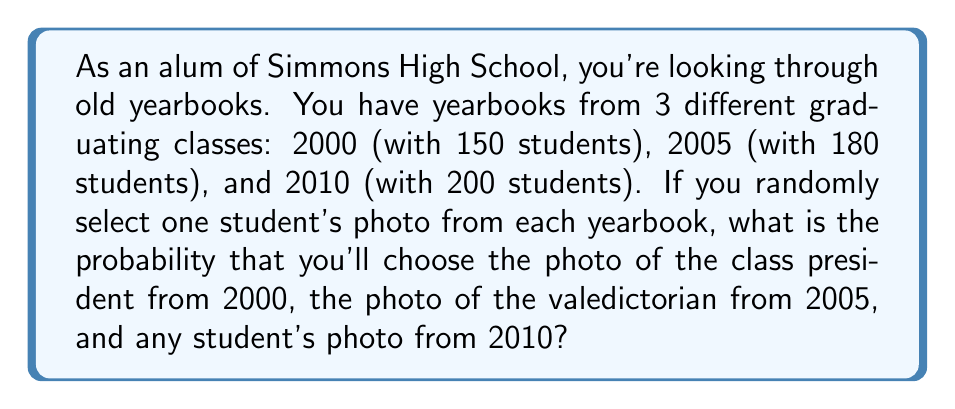Help me with this question. Let's approach this step-by-step:

1) For the year 2000:
   - There are 150 students in total.
   - We need to select the class president, which is 1 specific student.
   - Probability = $\frac{1}{150}$

2) For the year 2005:
   - There are 180 students in total.
   - We need to select the valedictorian, which is 1 specific student.
   - Probability = $\frac{1}{180}$

3) For the year 2010:
   - There are 200 students in total.
   - We can select any student, so all choices are favorable.
   - Probability = $\frac{200}{200} = 1$

4) Since we're selecting one photo from each yearbook independently, we need to multiply these probabilities:

   $$P(\text{total}) = P(2000) \times P(2005) \times P(2010)$$
   
   $$P(\text{total}) = \frac{1}{150} \times \frac{1}{180} \times 1$$

5) Simplifying:
   $$P(\text{total}) = \frac{1}{27000}$$

Therefore, the probability of this specific combination occurring is $\frac{1}{27000}$.
Answer: $\frac{1}{27000}$ 